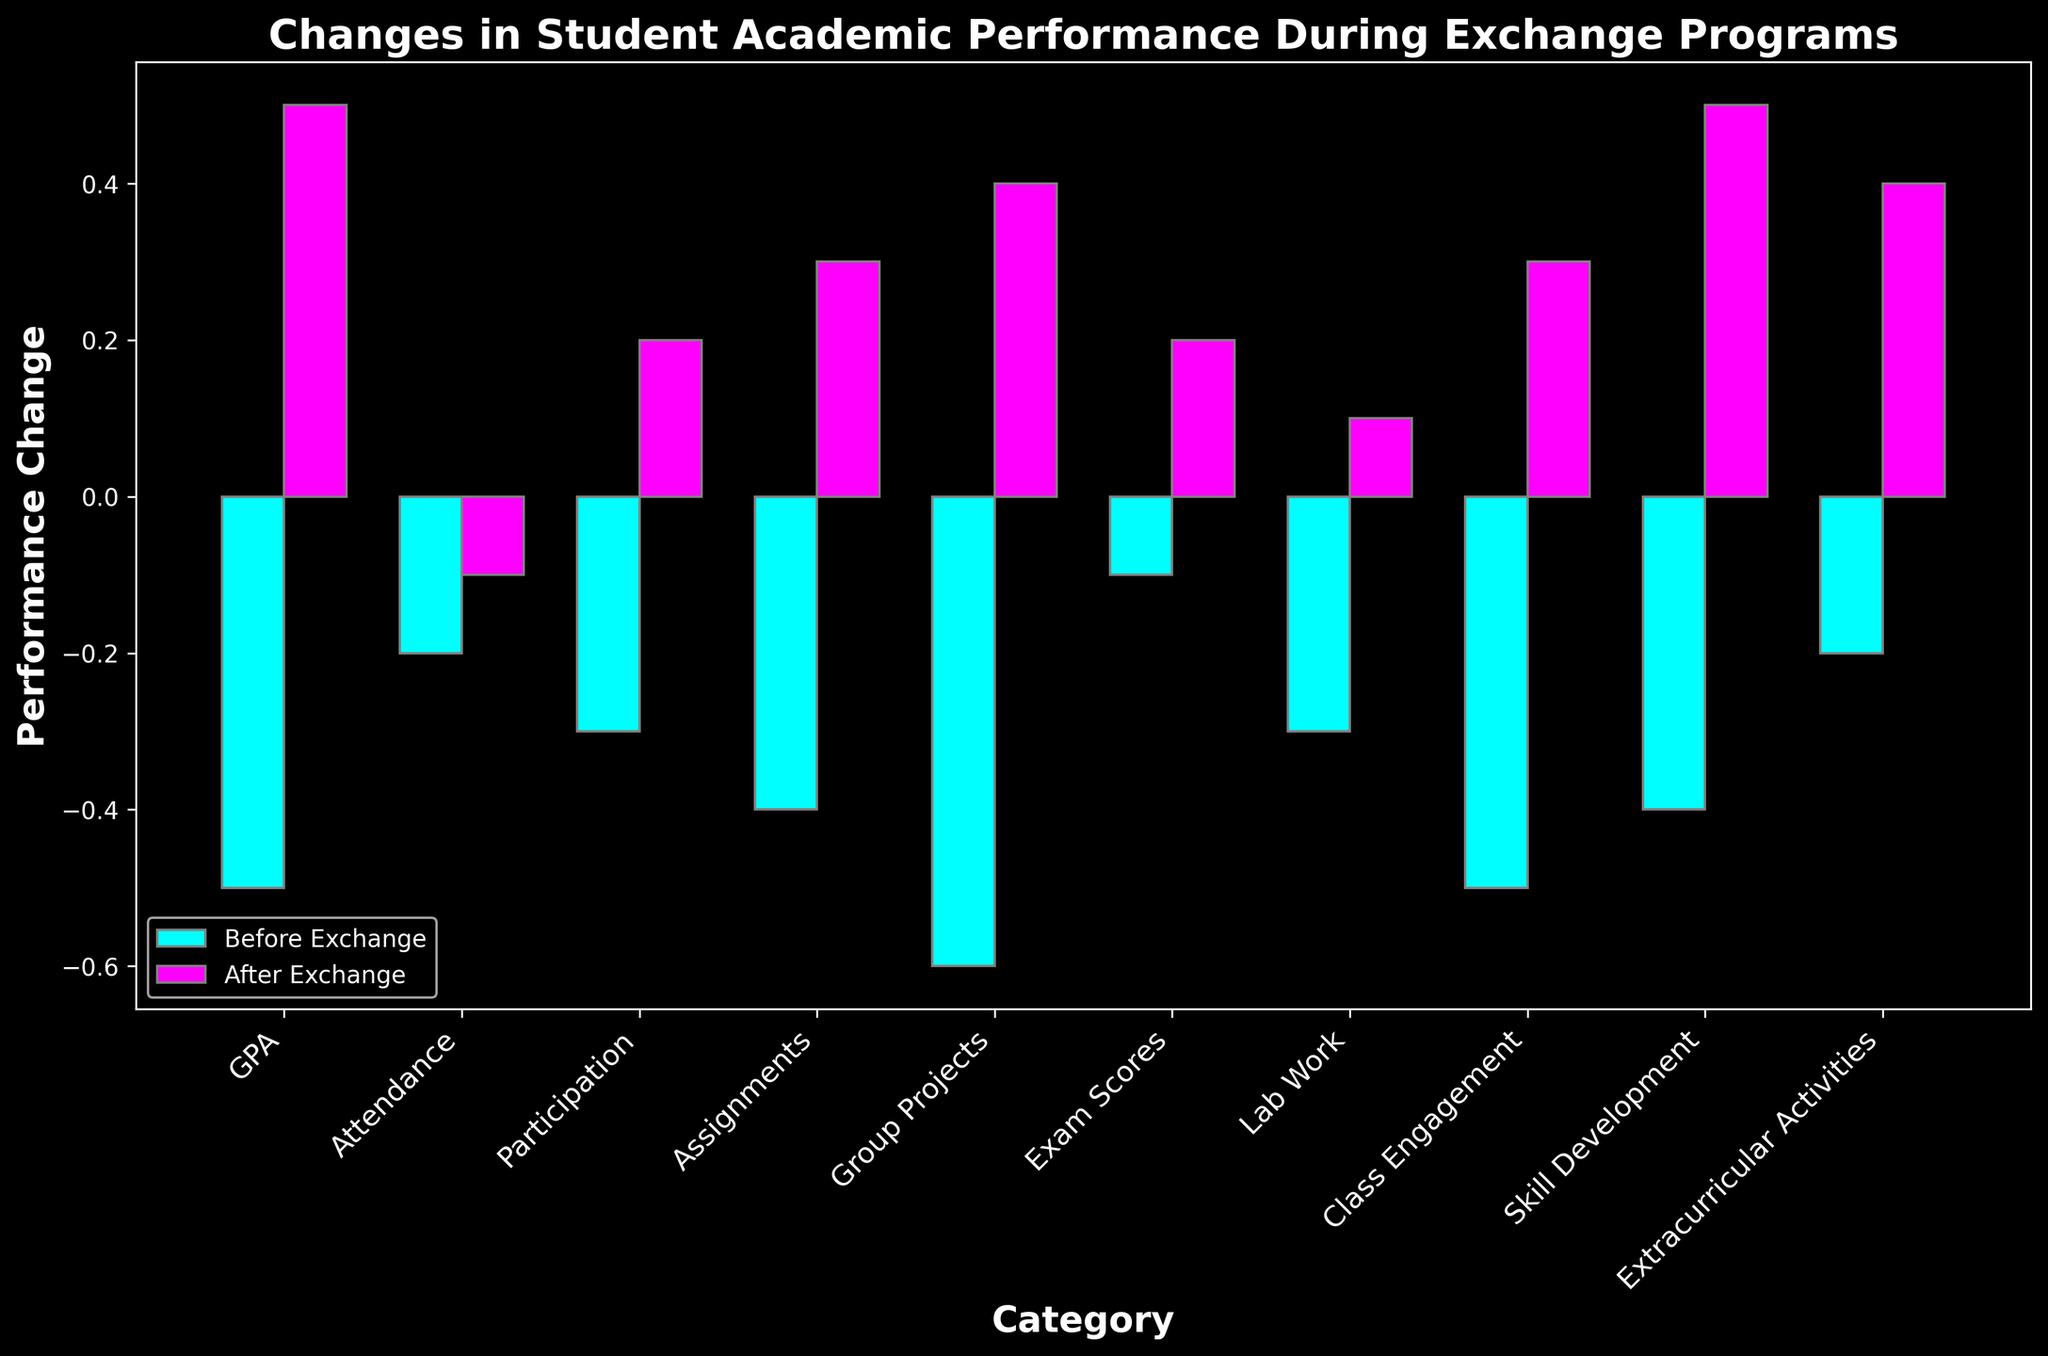Which category experienced the largest improvement in performance after the exchange program? To find the category with the largest improvement, compare the "After Exchange" values across all categories. The highest value is 0.5 seen in "GPA" and "Skill Development".
Answer: GPA, Skill Development Which category had a decrease in performance after the exchange program? Look at the "After Exchange" values and see if any of them are less than zero. All "After Exchange" values are greater than or equal to zero, so no category experienced a decrease.
Answer: None What is the difference in attendance performance before and after the exchange program? Subtract the "Attendance" value before exchange (-0.2) from the after exchange value (-0.1). The difference is calculated as -0.1 - (-0.2) = 0.1.
Answer: 0.1 How many categories showed a positive change in performance after the exchange program? Count the number of "After Exchange" values that are greater than zero. There are 8 categories with positive changes.
Answer: 8 Which categories showed a negative change in performance before the exchange program? Identify the categories where the "Before Exchange" values are less than zero. All the categories have negative "Before Exchange" values.
Answer: All categories Compare the performance change in "Lab Work" before and after the exchange program. Look at the bar heights for "Lab Work". Before Exchange is -0.3 and After Exchange is 0.1. Compare these two values. After Exchange is higher than Before by 0.4.
Answer: After is higher by 0.4 What's the average performance change after the exchange program for all categories? Sum up all "After Exchange" values: 0.5 + (-0.1) + 0.2 + 0.3 + 0.4 + 0.2 + 0.1 + 0.3 + 0.5 + 0.4 = 2.8. Divide by the number of categories (10) to get the average: 2.8 / 10 = 0.28.
Answer: 0.28 How much did the performance in "Group Projects" change from before to after the exchange program? Subtract the "Group Projects" value before exchange (-0.6) from the after exchange value (0.4). The change is 0.4 - (-0.6) = 1.0.
Answer: 1.0 Which category had the smallest improvement in performance after the exchange program? Look for the smallest positive "After Exchange" value. The smallest positive value is 0.1, which is in the "Lab Work" category.
Answer: Lab Work 